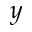<formula> <loc_0><loc_0><loc_500><loc_500>y</formula> 